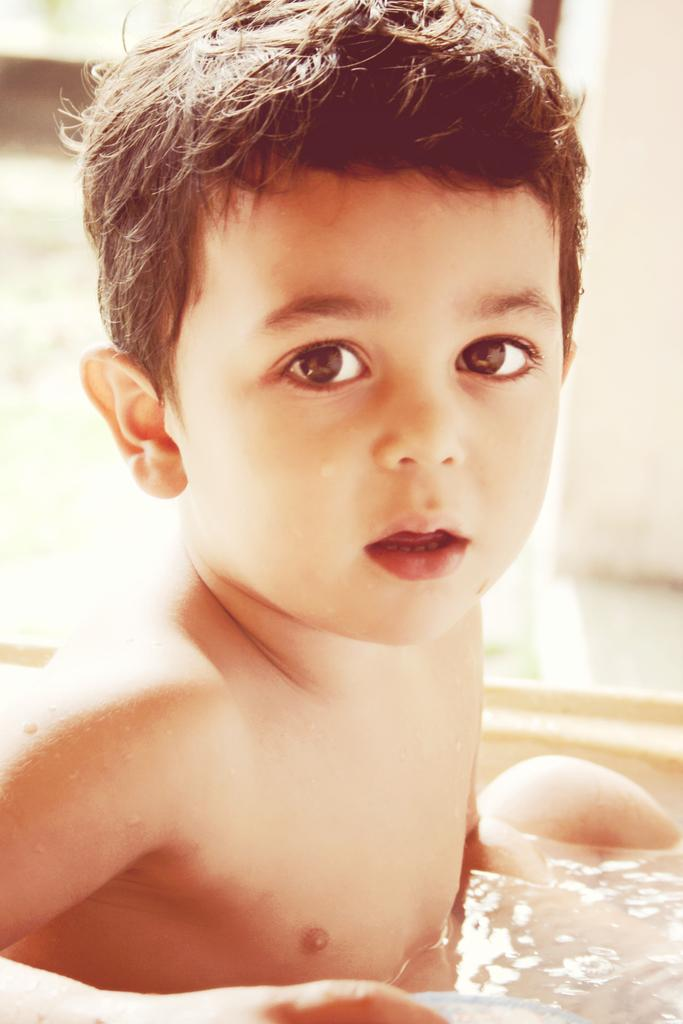Who is present in the image? There is a boy in the image. What is the boy doing in the image? The boy is in a water tub. What book is the boy reading in the image? There is no book or reading activity present in the image; the boy is in a water tub. 